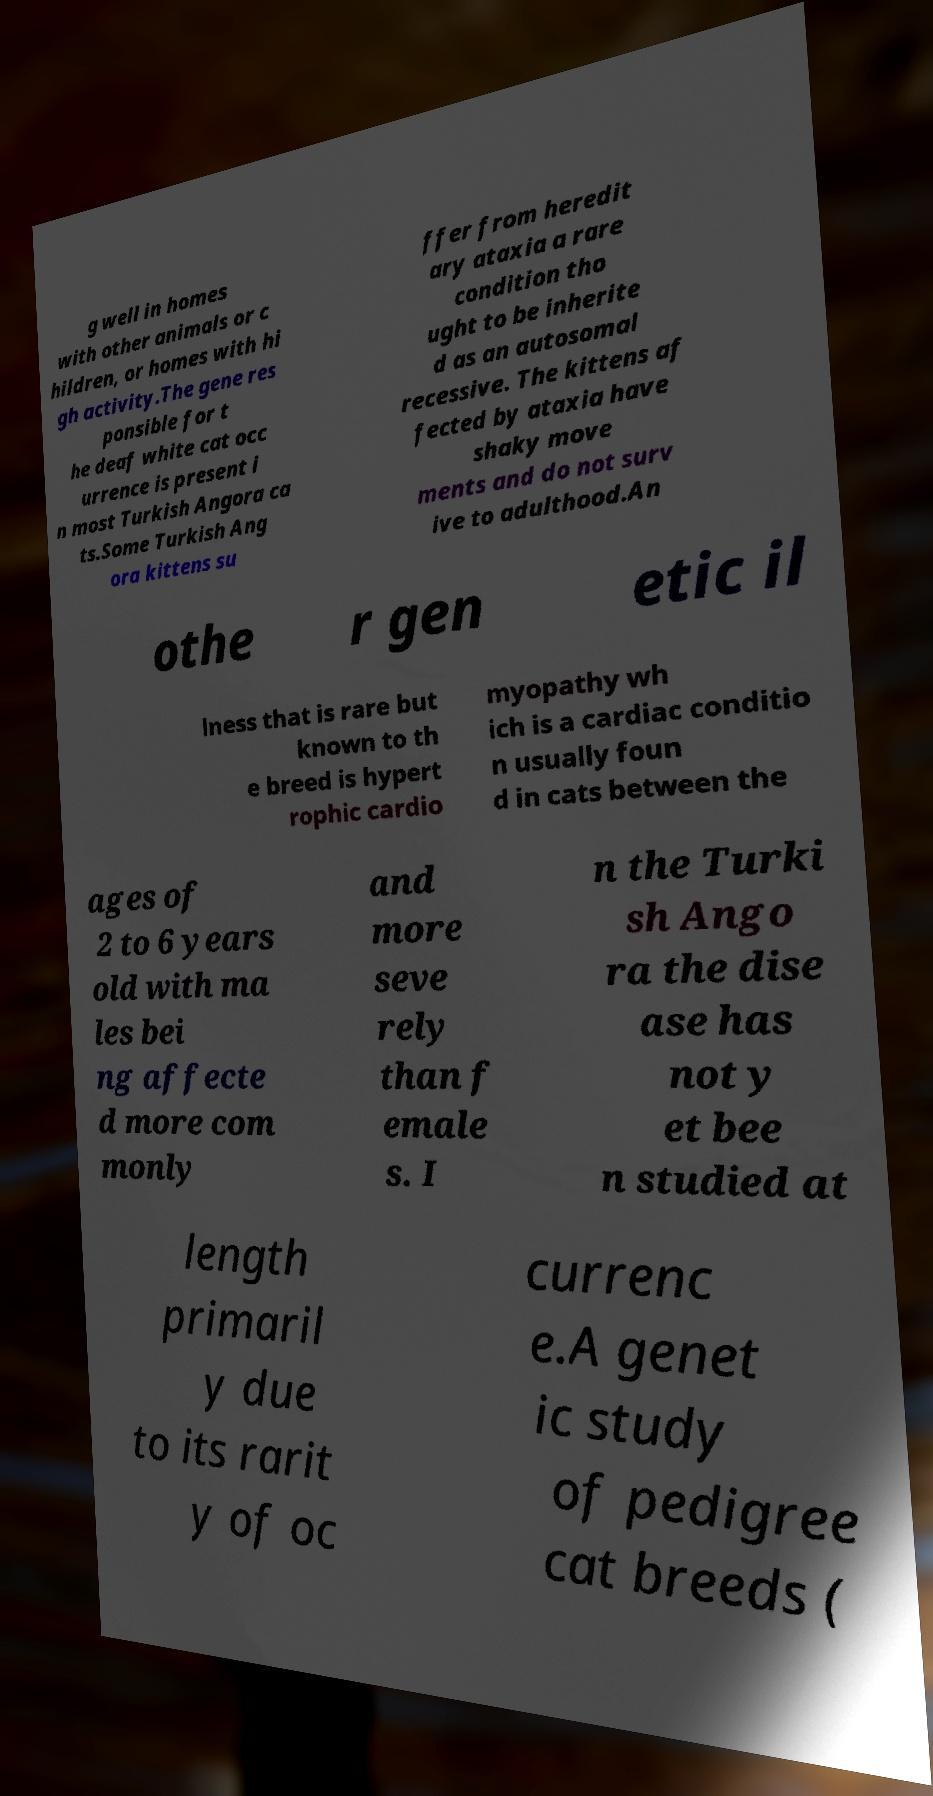What messages or text are displayed in this image? I need them in a readable, typed format. g well in homes with other animals or c hildren, or homes with hi gh activity.The gene res ponsible for t he deaf white cat occ urrence is present i n most Turkish Angora ca ts.Some Turkish Ang ora kittens su ffer from heredit ary ataxia a rare condition tho ught to be inherite d as an autosomal recessive. The kittens af fected by ataxia have shaky move ments and do not surv ive to adulthood.An othe r gen etic il lness that is rare but known to th e breed is hypert rophic cardio myopathy wh ich is a cardiac conditio n usually foun d in cats between the ages of 2 to 6 years old with ma les bei ng affecte d more com monly and more seve rely than f emale s. I n the Turki sh Ango ra the dise ase has not y et bee n studied at length primaril y due to its rarit y of oc currenc e.A genet ic study of pedigree cat breeds ( 